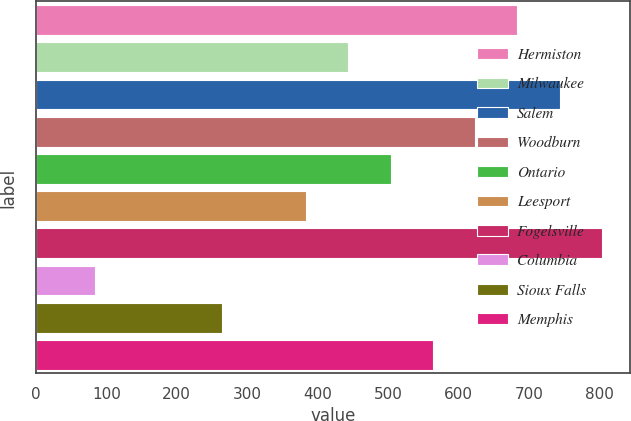<chart> <loc_0><loc_0><loc_500><loc_500><bar_chart><fcel>Hermiston<fcel>Milwaukee<fcel>Salem<fcel>Woodburn<fcel>Ontario<fcel>Leesport<fcel>Fogelsville<fcel>Columbia<fcel>Sioux Falls<fcel>Memphis<nl><fcel>683.9<fcel>443.82<fcel>743.92<fcel>623.88<fcel>503.84<fcel>383.8<fcel>803.94<fcel>83.7<fcel>263.76<fcel>563.86<nl></chart> 